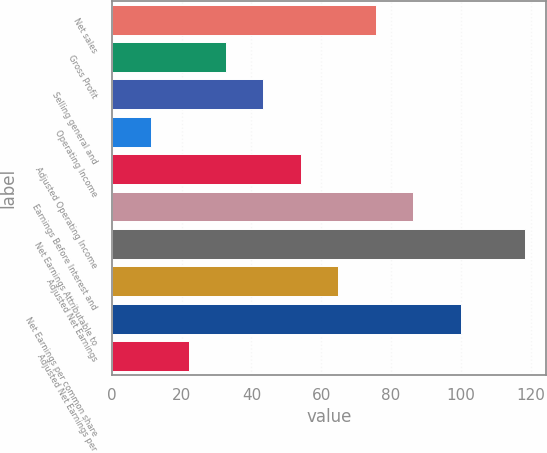Convert chart to OTSL. <chart><loc_0><loc_0><loc_500><loc_500><bar_chart><fcel>Net sales<fcel>Gross Profit<fcel>Selling general and<fcel>Operating Income<fcel>Adjusted Operating Income<fcel>Earnings Before Interest and<fcel>Net Earnings Attributable to<fcel>Adjusted Net Earnings<fcel>Net Earnings per common share<fcel>Adjusted Net Earnings per<nl><fcel>75.56<fcel>32.72<fcel>43.43<fcel>11.3<fcel>54.14<fcel>86.27<fcel>118.4<fcel>64.85<fcel>100<fcel>22.01<nl></chart> 